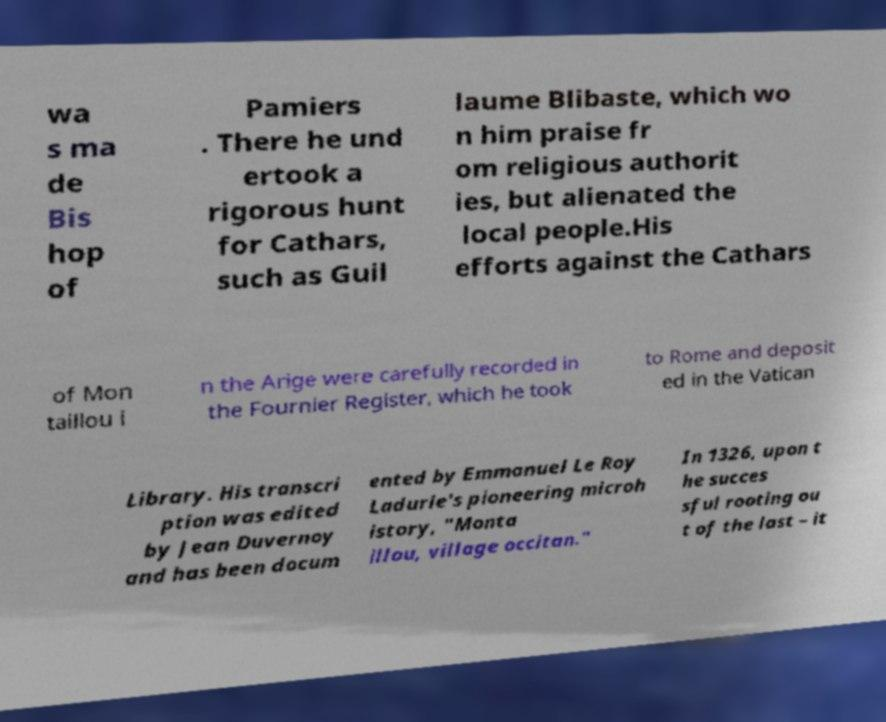I need the written content from this picture converted into text. Can you do that? wa s ma de Bis hop of Pamiers . There he und ertook a rigorous hunt for Cathars, such as Guil laume Blibaste, which wo n him praise fr om religious authorit ies, but alienated the local people.His efforts against the Cathars of Mon taillou i n the Arige were carefully recorded in the Fournier Register, which he took to Rome and deposit ed in the Vatican Library. His transcri ption was edited by Jean Duvernoy and has been docum ented by Emmanuel Le Roy Ladurie's pioneering microh istory, "Monta illou, village occitan." In 1326, upon t he succes sful rooting ou t of the last – it 